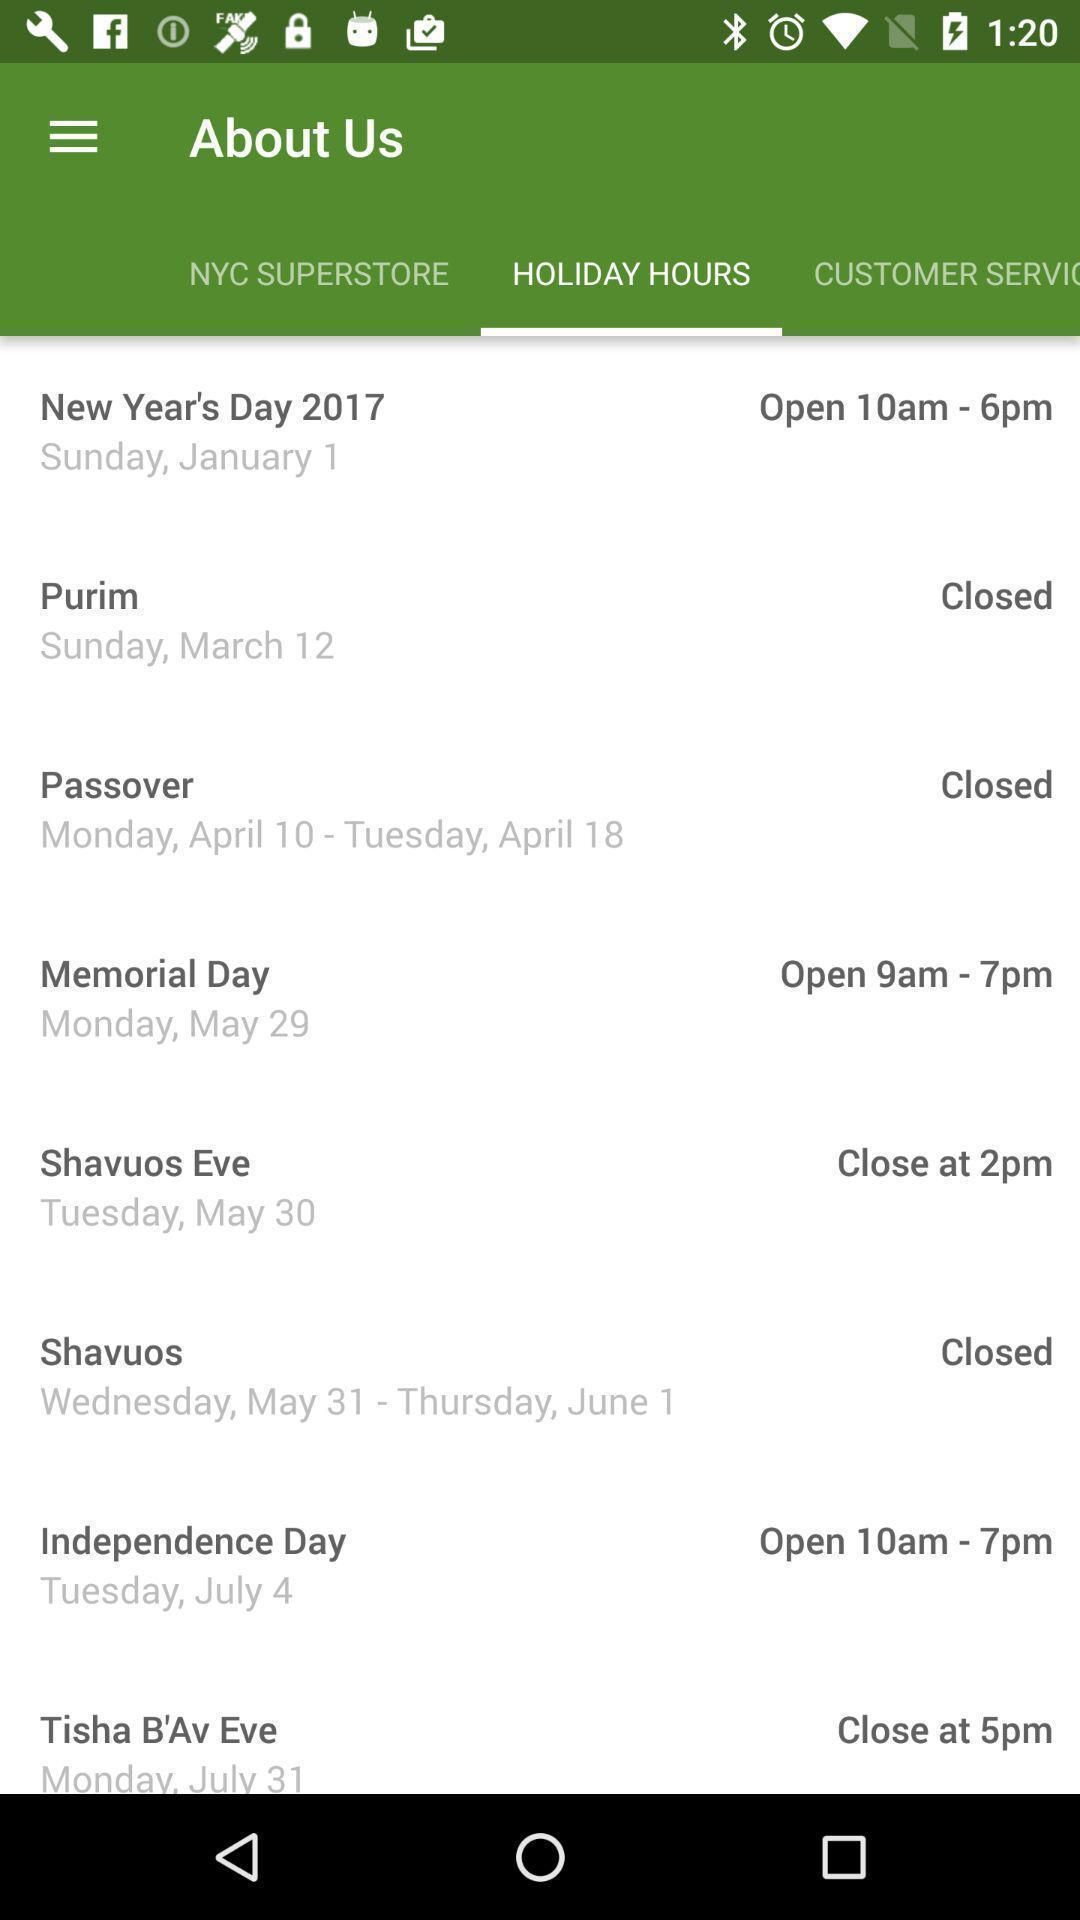Provide a textual representation of this image. Page displaying with list of holiday hours and days. 